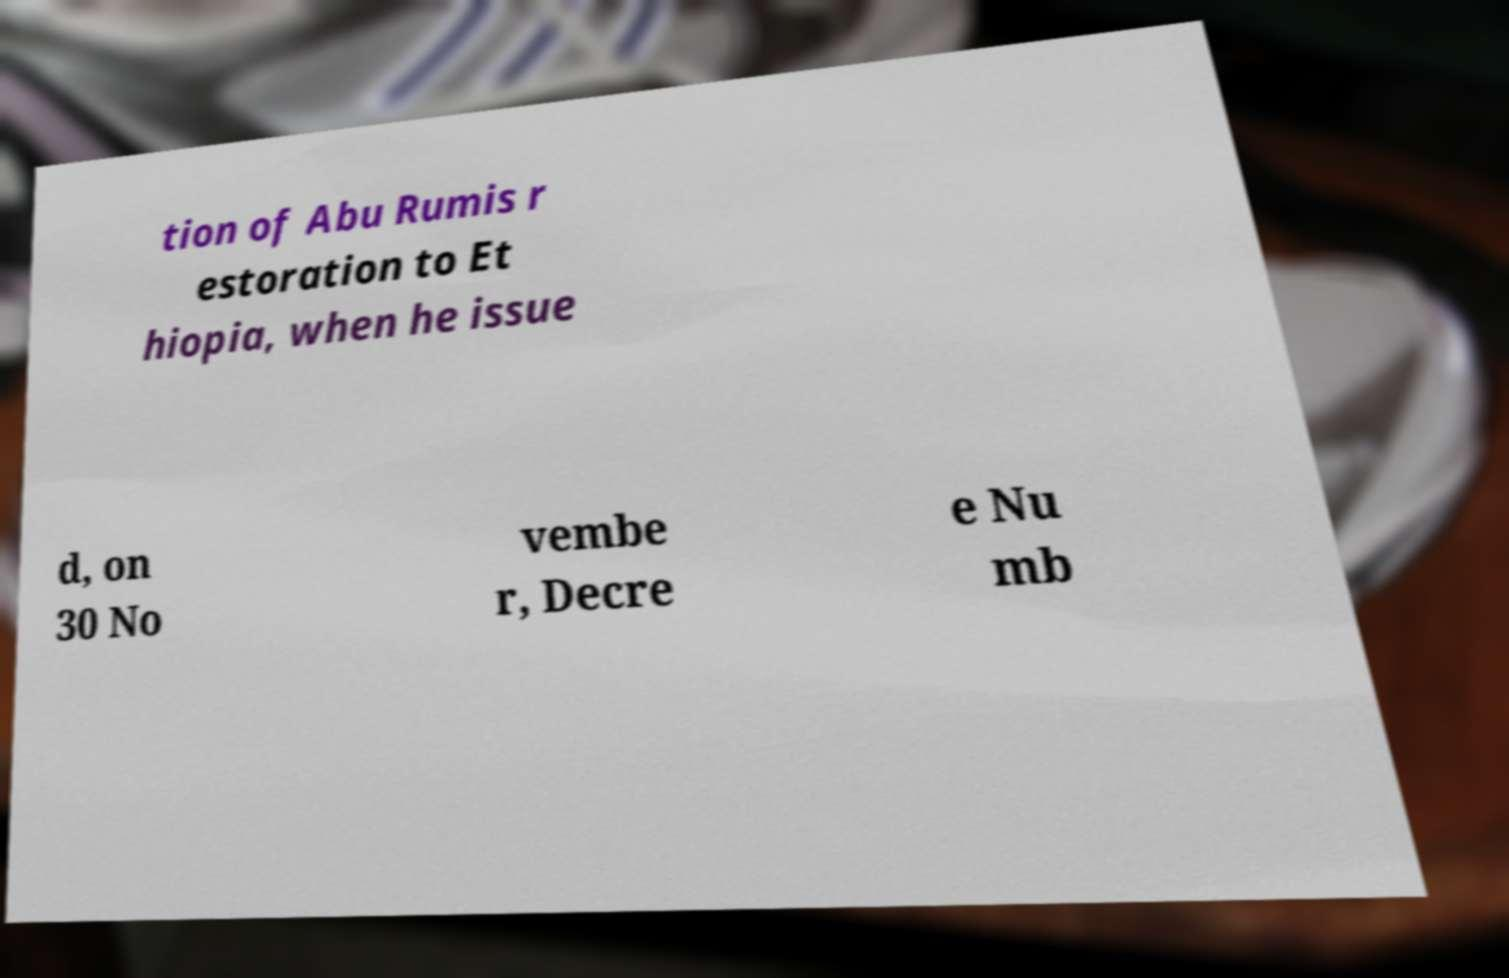Can you accurately transcribe the text from the provided image for me? tion of Abu Rumis r estoration to Et hiopia, when he issue d, on 30 No vembe r, Decre e Nu mb 